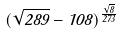Convert formula to latex. <formula><loc_0><loc_0><loc_500><loc_500>( \sqrt { 2 8 9 } - 1 0 8 ) ^ { \frac { \sqrt { 8 } } { 2 7 3 } }</formula> 